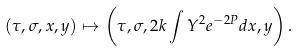Convert formula to latex. <formula><loc_0><loc_0><loc_500><loc_500>( \tau , \sigma , x , y ) \mapsto \left ( \tau , \sigma , 2 k \int { Y ^ { 2 } e ^ { - 2 P } d x } , y \right ) .</formula> 